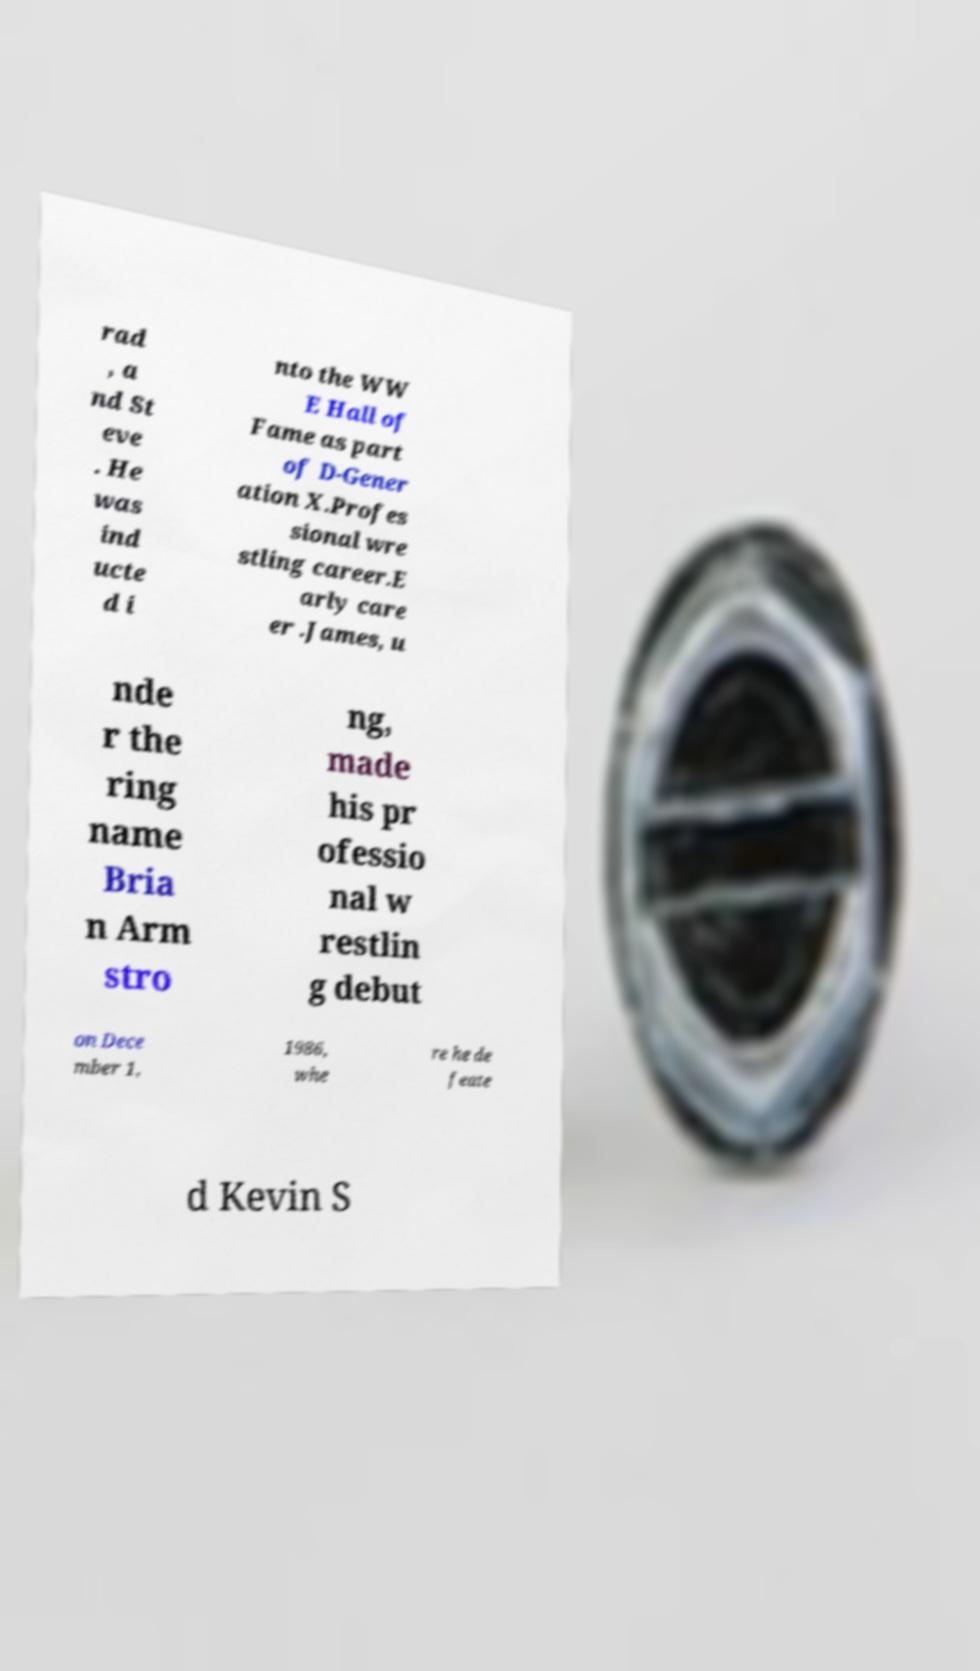What messages or text are displayed in this image? I need them in a readable, typed format. rad , a nd St eve . He was ind ucte d i nto the WW E Hall of Fame as part of D-Gener ation X.Profes sional wre stling career.E arly care er .James, u nde r the ring name Bria n Arm stro ng, made his pr ofessio nal w restlin g debut on Dece mber 1, 1986, whe re he de feate d Kevin S 